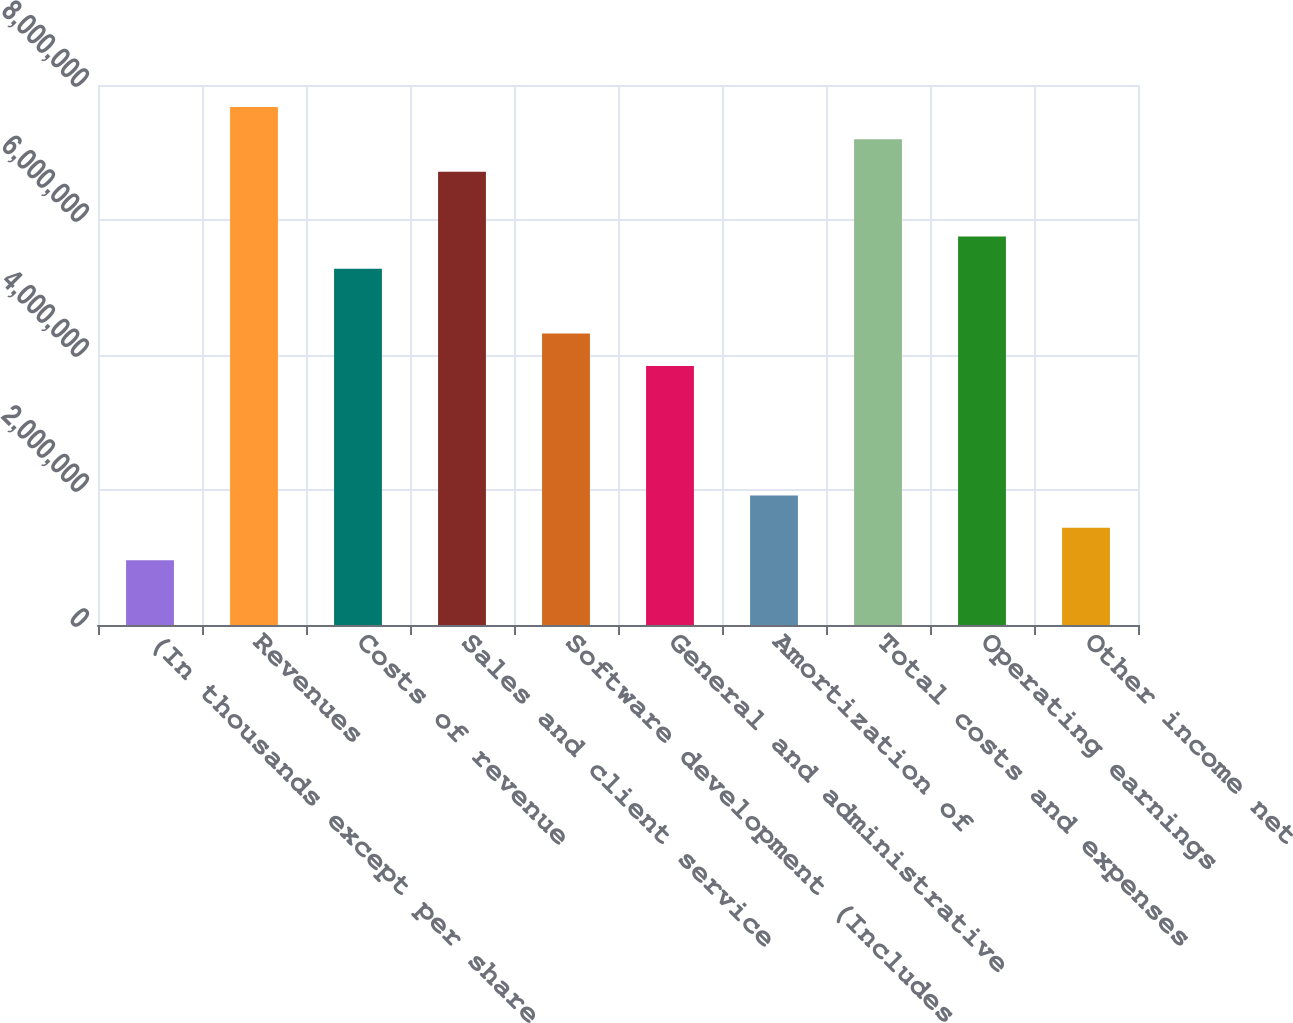Convert chart to OTSL. <chart><loc_0><loc_0><loc_500><loc_500><bar_chart><fcel>(In thousands except per share<fcel>Revenues<fcel>Costs of revenue<fcel>Sales and client service<fcel>Software development (Includes<fcel>General and administrative<fcel>Amortization of<fcel>Total costs and expenses<fcel>Operating earnings<fcel>Other income net<nl><fcel>959296<fcel>7.67436e+06<fcel>5.27612e+06<fcel>6.71506e+06<fcel>4.31683e+06<fcel>3.83718e+06<fcel>1.91859e+06<fcel>7.19471e+06<fcel>5.75577e+06<fcel>1.43894e+06<nl></chart> 